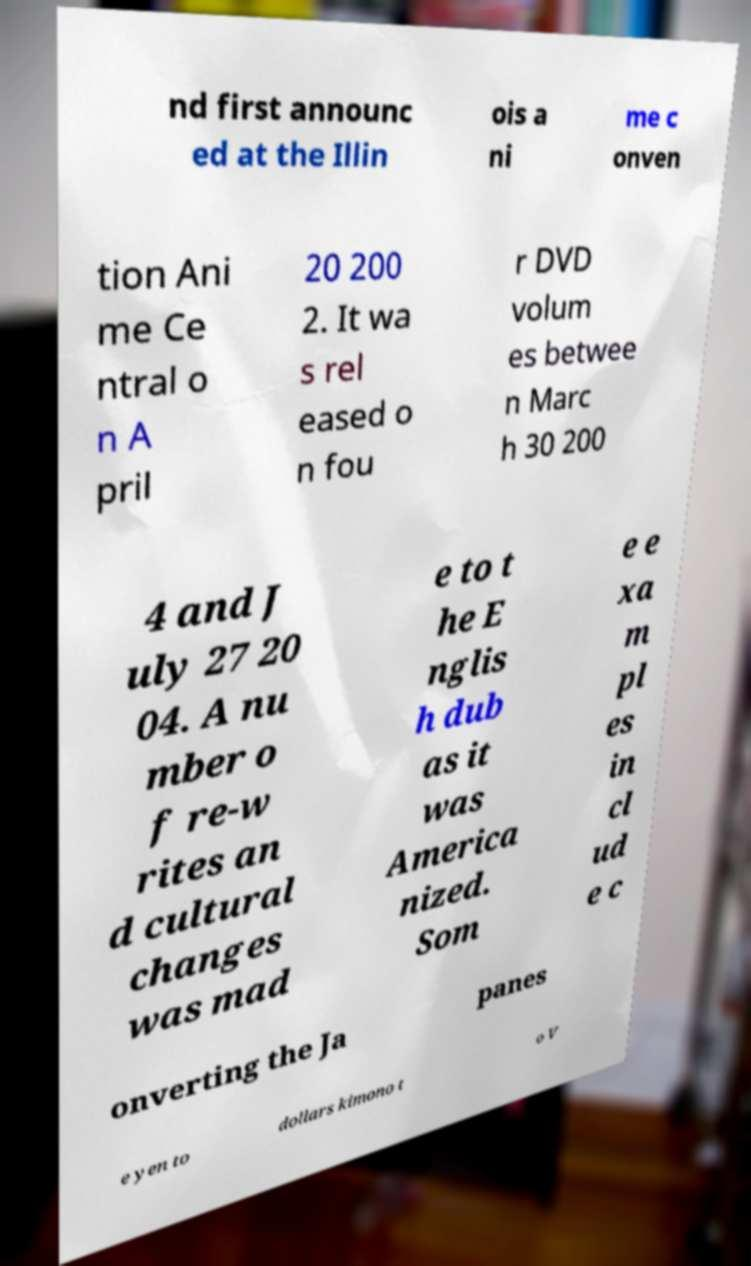I need the written content from this picture converted into text. Can you do that? nd first announc ed at the Illin ois a ni me c onven tion Ani me Ce ntral o n A pril 20 200 2. It wa s rel eased o n fou r DVD volum es betwee n Marc h 30 200 4 and J uly 27 20 04. A nu mber o f re-w rites an d cultural changes was mad e to t he E nglis h dub as it was America nized. Som e e xa m pl es in cl ud e c onverting the Ja panes e yen to dollars kimono t o V 